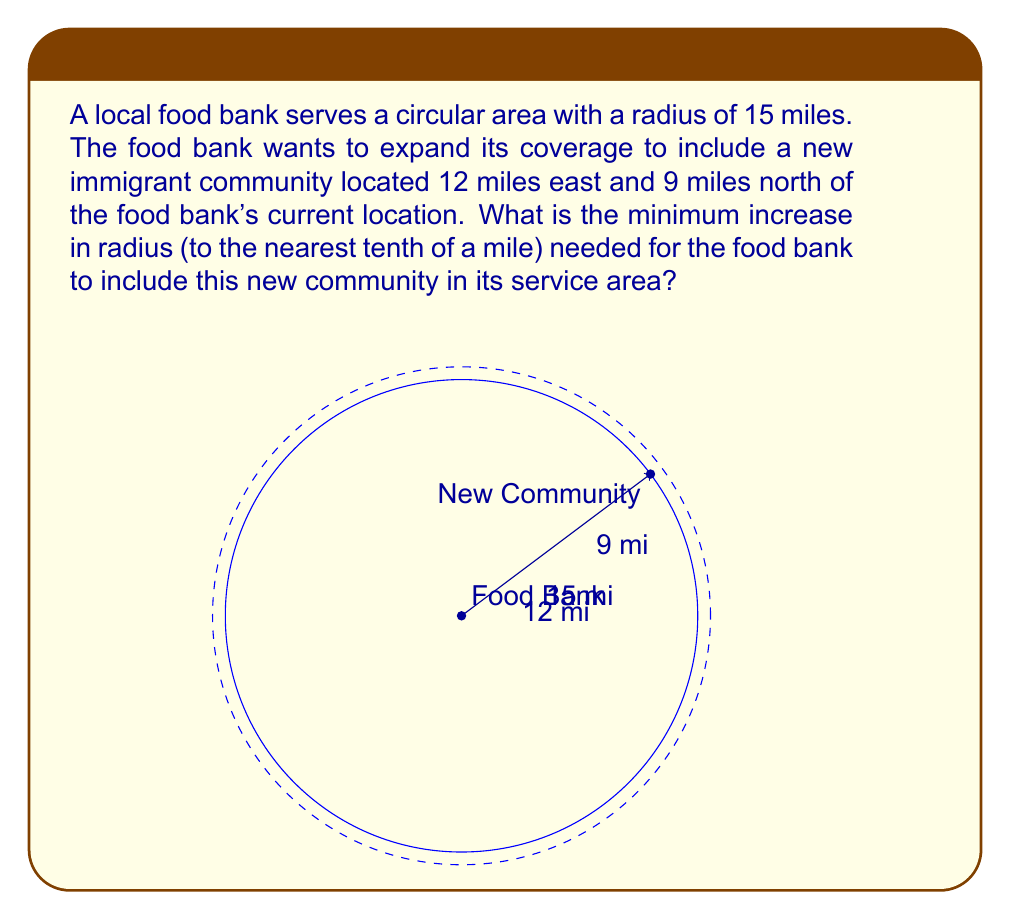Can you answer this question? To solve this problem, we'll use the Pythagorean theorem and trigonometric functions. Let's break it down step by step:

1) First, we need to find the distance from the food bank to the new community. We can use the Pythagorean theorem:

   $$d = \sqrt{12^2 + 9^2} = \sqrt{144 + 81} = \sqrt{225} = 15$$

2) Now, we know that the new community is exactly 15 miles away from the food bank. However, the current service area has a radius of 15 miles, which means the new community is just on the edge of the current coverage.

3) To include the new community, we need to increase the radius slightly. The minimum increase would be the difference between the exact distance (15 miles) and the current radius (15 miles).

4) However, since we're asked to round to the nearest tenth of a mile, and 15 is exactly on the boundary, we need to increase the radius by at least 0.1 miles to ensure coverage.

5) Therefore, the minimum increase in radius needed is 0.1 miles.

This problem demonstrates how trigonometry and the Pythagorean theorem can be used in real-world scenarios, such as determining service area coverage for social services like food banks.
Answer: The minimum increase in radius needed is 0.1 miles. 